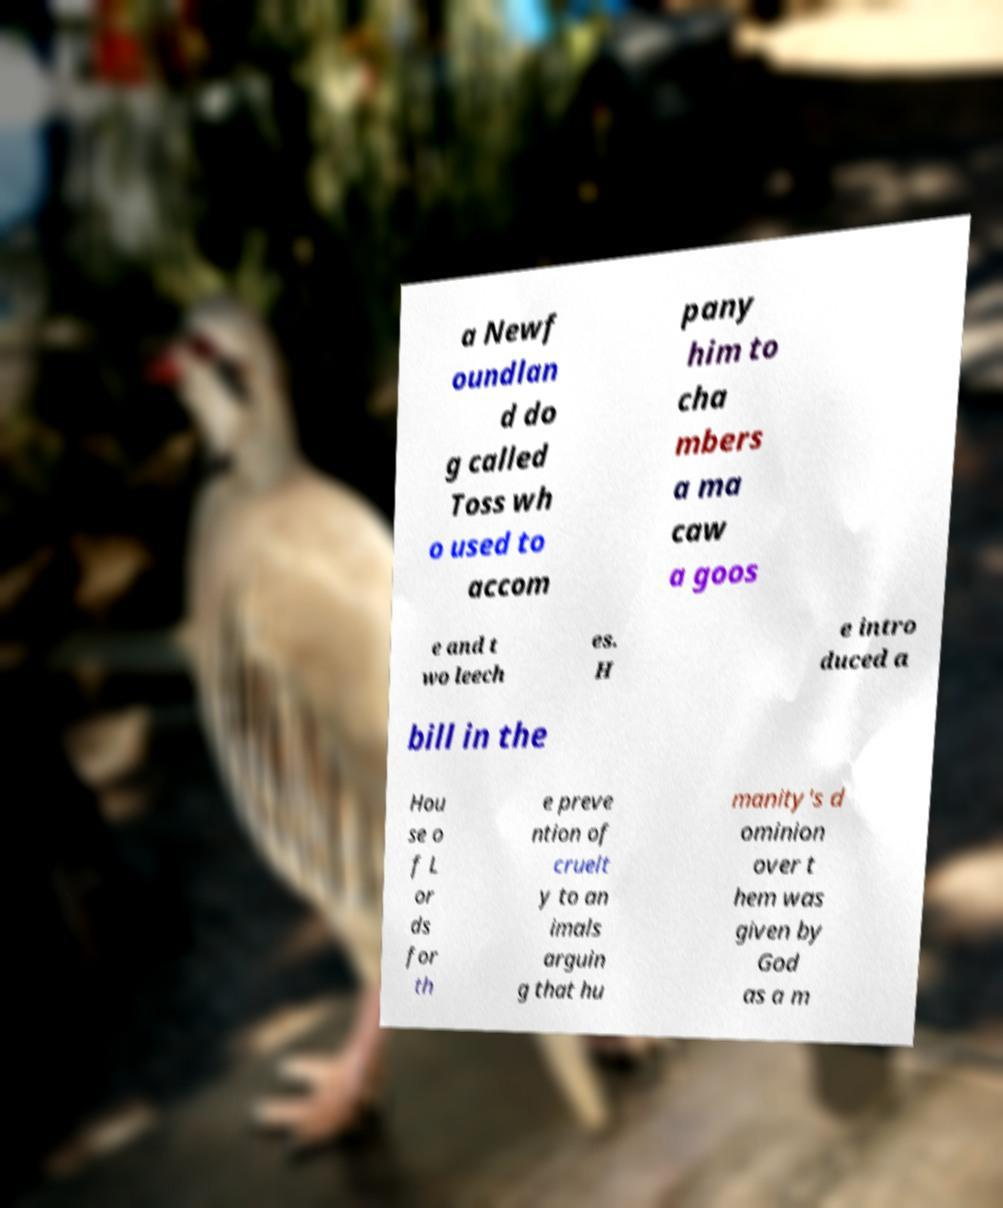What messages or text are displayed in this image? I need them in a readable, typed format. a Newf oundlan d do g called Toss wh o used to accom pany him to cha mbers a ma caw a goos e and t wo leech es. H e intro duced a bill in the Hou se o f L or ds for th e preve ntion of cruelt y to an imals arguin g that hu manity's d ominion over t hem was given by God as a m 